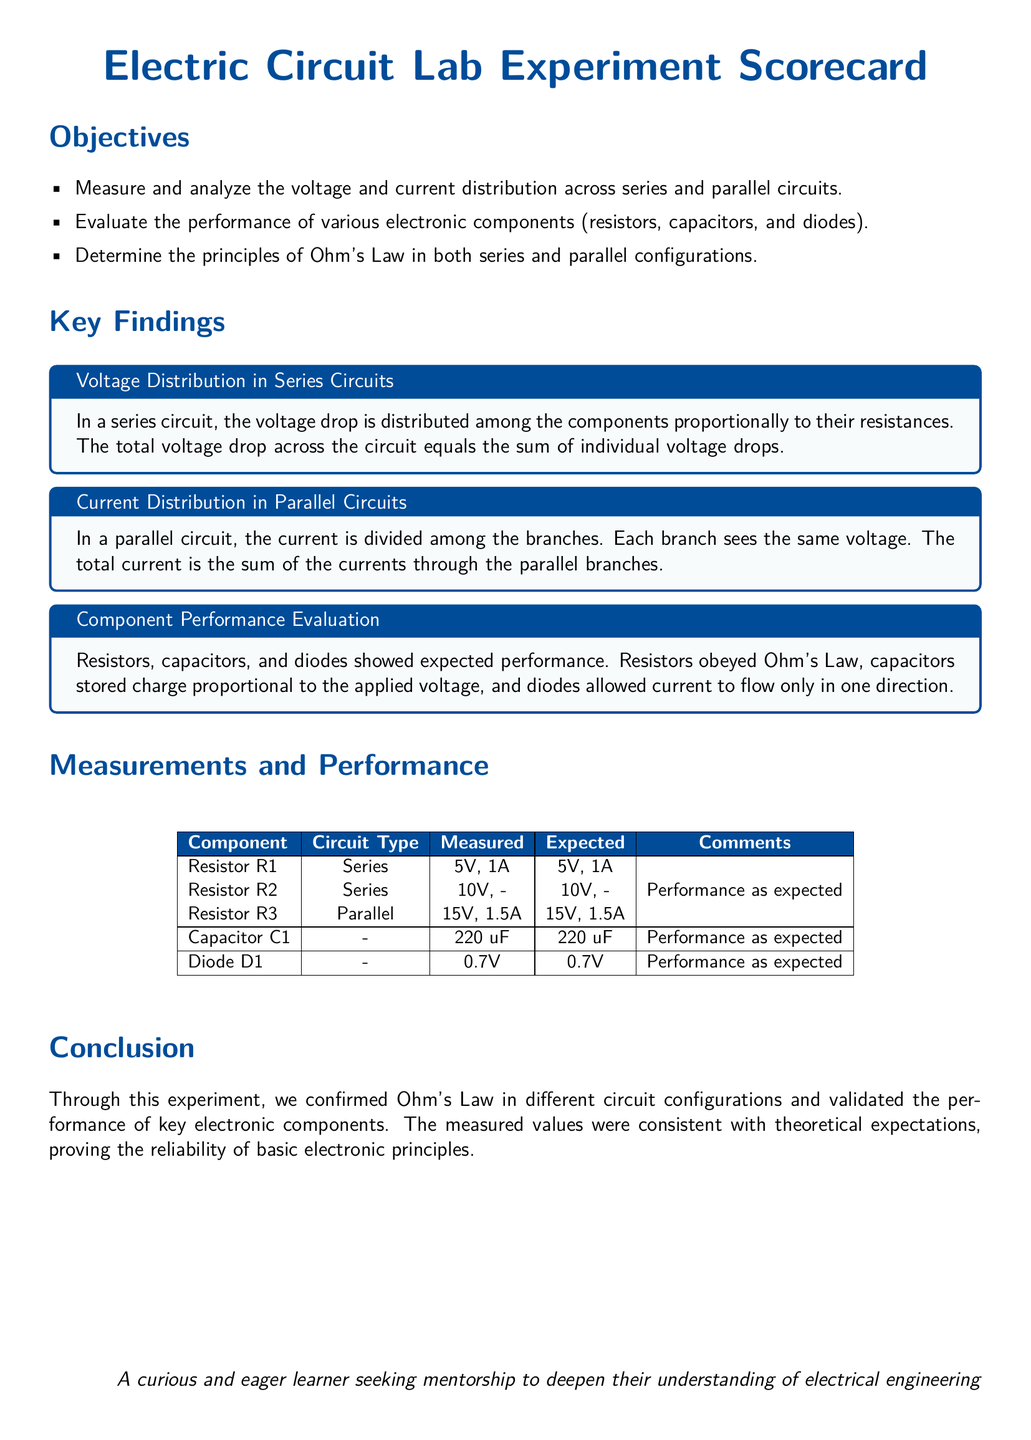What is the primary objective of the experiment? The primary objective is to measure and analyze the voltage and current distribution across series and parallel circuits.
Answer: Measure and analyze the voltage and current distribution across series and parallel circuits What is the voltage drop across resistor R1? The measured voltage drop across resistor R1 is specified in the measurements table.
Answer: 5V What type of circuit is resistor R3 connected to? The type of circuit for resistor R3 is indicated in the measurements section.
Answer: Parallel What is the expected voltage for diode D1? The expected voltage for diode D1 is provided in the performance evaluation table.
Answer: 0.7V How many components were evaluated in the performance section? The document lists the components for evaluation in the performance section.
Answer: 5 What finding supports Ohm's Law in series circuits? The scorecard discusses voltage distribution among components.
Answer: Voltage drop is distributed among the components What is the measured capacitance of capacitor C1? The measured capacitance for capacitor C1 is noted in the Measurements and Performance section.
Answer: 220 uF What do capacitors do in response to voltage? The scorecard describes the relationship between voltage and capacitors in the findings.
Answer: Store charge proportional to the applied voltage 